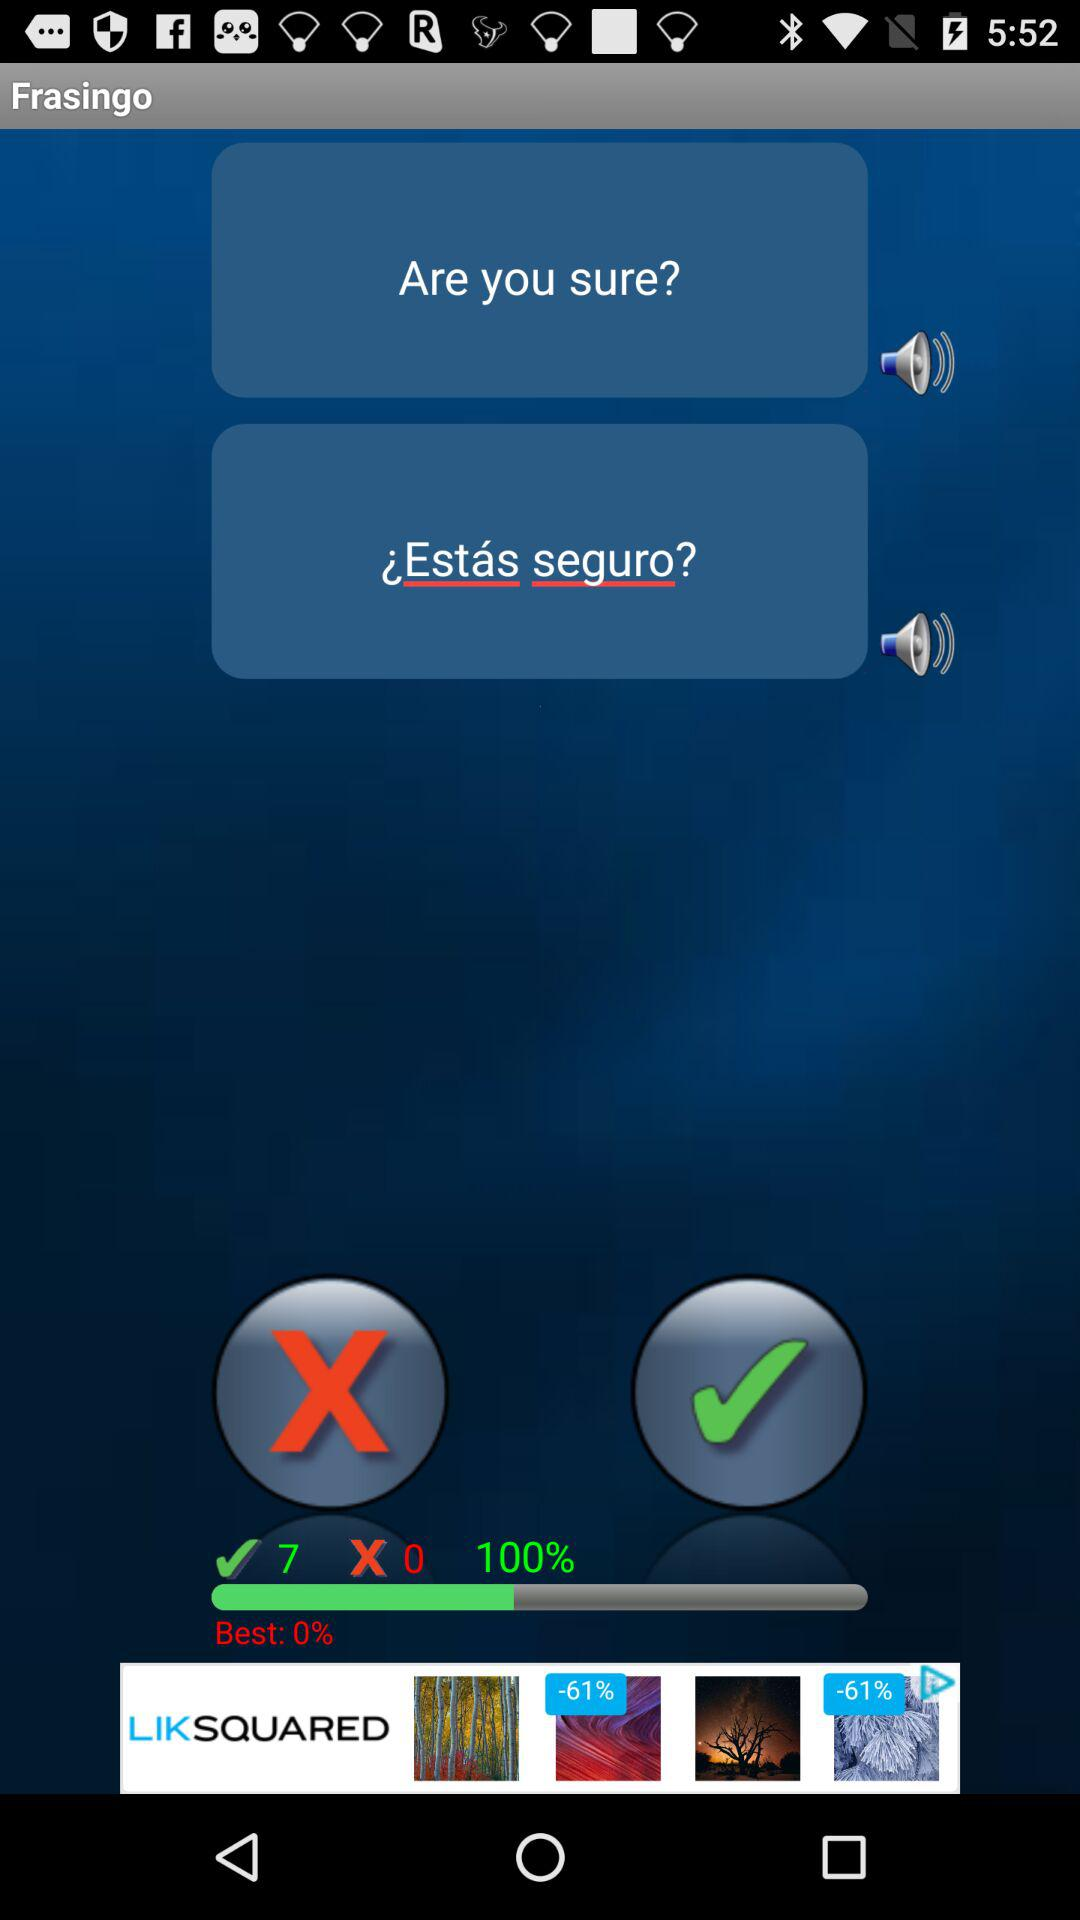What's the number of wrong answers? The number of wrong answers is 0. 